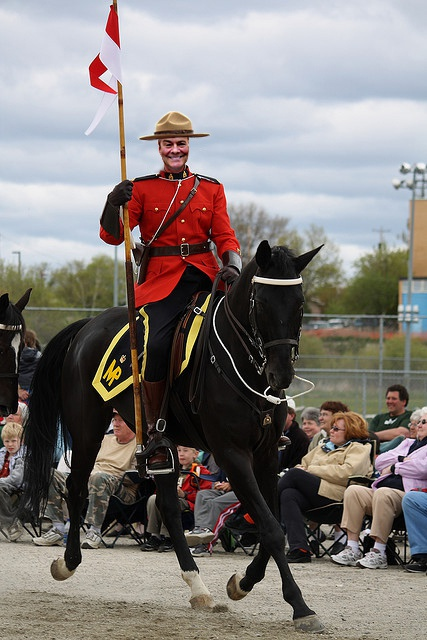Describe the objects in this image and their specific colors. I can see horse in lightgray, black, gray, darkgray, and maroon tones, people in lightgray, black, brown, and maroon tones, people in lightgray, black, tan, and gray tones, people in lightgray, darkgray, black, gray, and lavender tones, and people in lightgray, black, gray, darkgray, and tan tones in this image. 